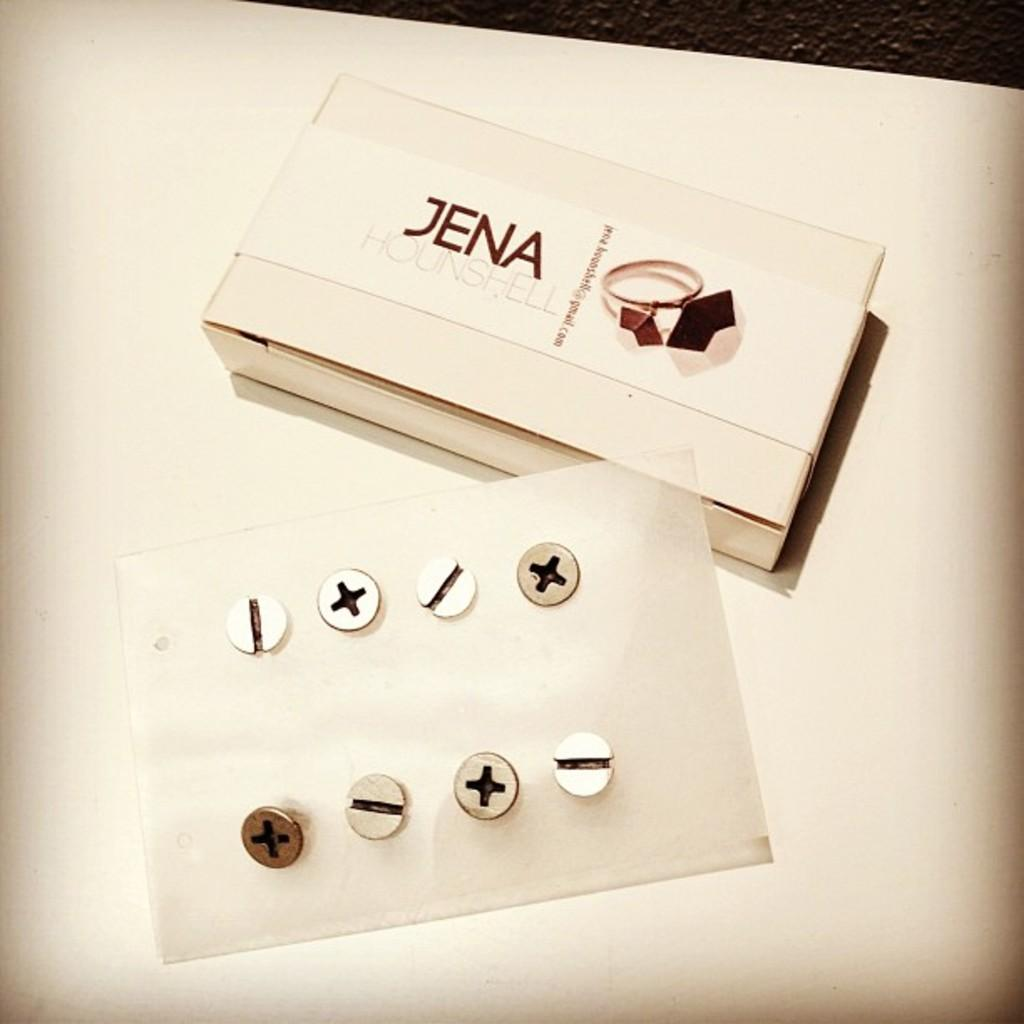What objects are fixed to the surface in the image? There are screws fixed to a surface in the image. What else can be seen on the surface? There is a box on the surface. What is written or printed on the box? The box has text on it. What is the color of the surface the screws and box are on? The surface is white in color. How many cows are visible in the image? There are no cows present in the image. What type of battle is taking place in the image? There is no battle depicted in the image. 